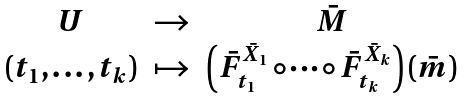<formula> <loc_0><loc_0><loc_500><loc_500>\begin{array} { c c c } U & \to & \bar { M } \\ ( t _ { 1 } , \dots , t _ { k } ) & \mapsto & \left ( \bar { F } _ { t _ { 1 } } ^ { \bar { X } _ { 1 } } \circ \dots \circ \bar { F } _ { t _ { k } } ^ { \bar { X } _ { k } } \right ) ( \bar { m } ) \end{array}</formula> 